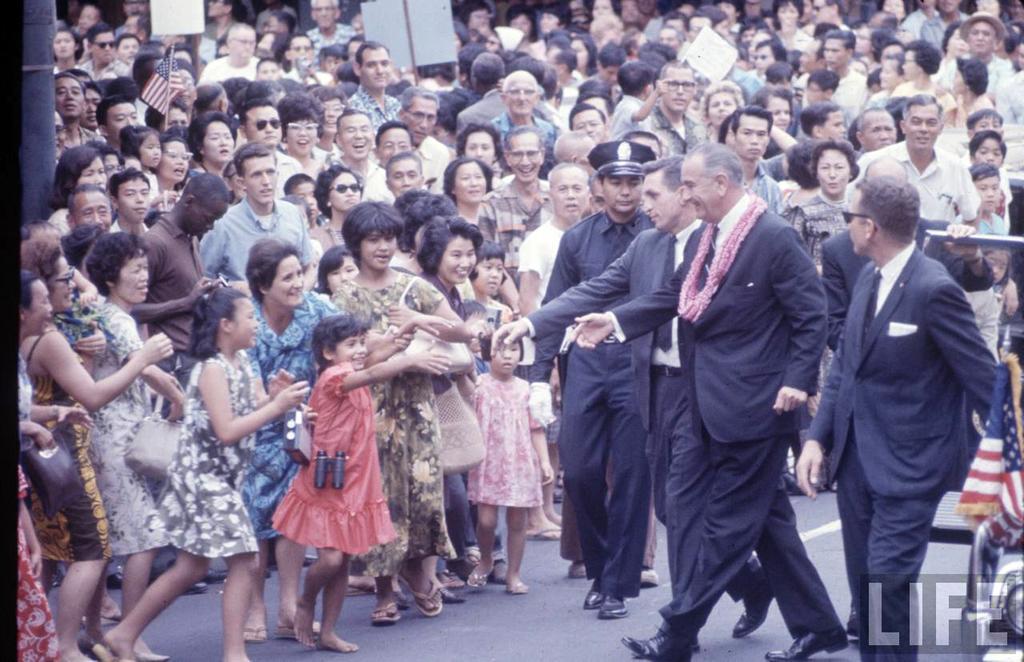How would you summarize this image in a sentence or two? In the center of the image there are group of people walking on the road. In the background there is a building. 